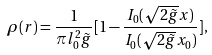Convert formula to latex. <formula><loc_0><loc_0><loc_500><loc_500>\rho ( r ) = \frac { 1 } { \pi l _ { 0 } ^ { 2 } \tilde { g } } [ 1 - \frac { I _ { 0 } ( \sqrt { 2 \tilde { g } } x ) } { I _ { 0 } ( \sqrt { 2 \tilde { g } } x _ { 0 } ) } ] ,</formula> 